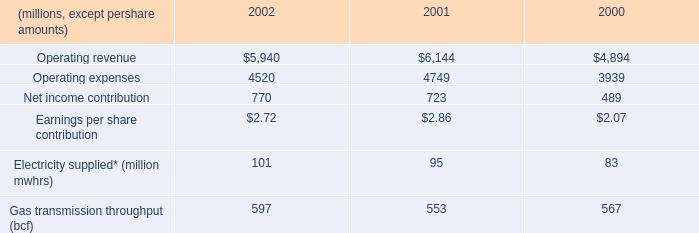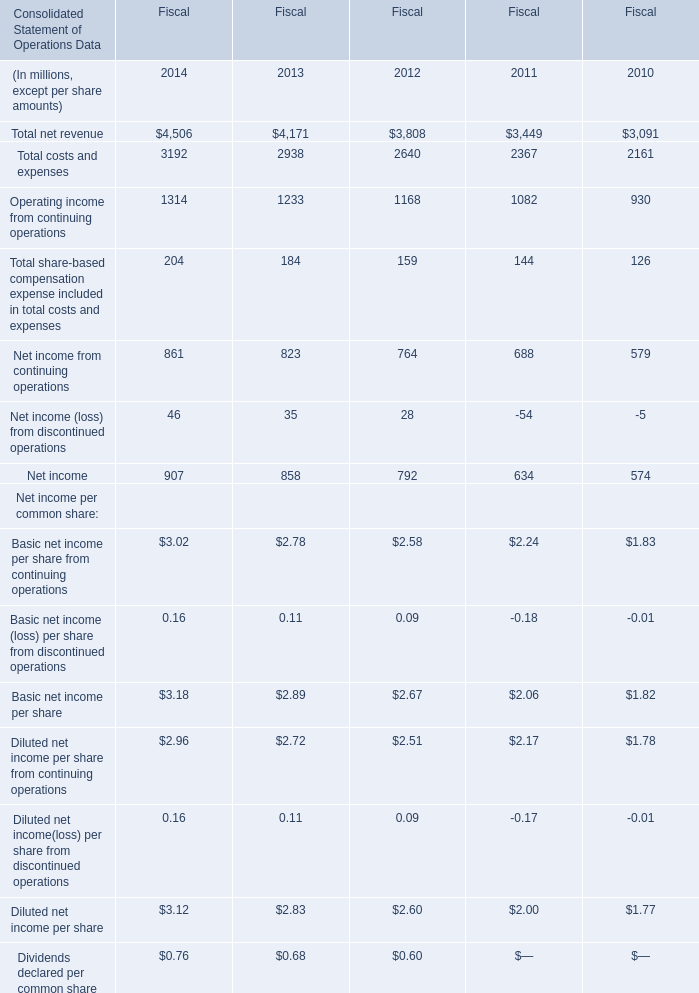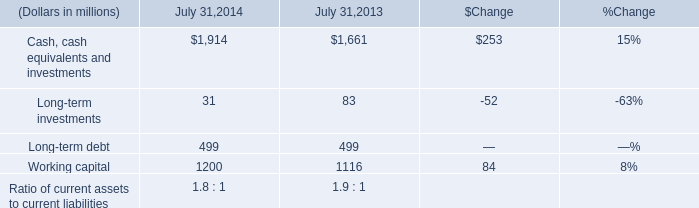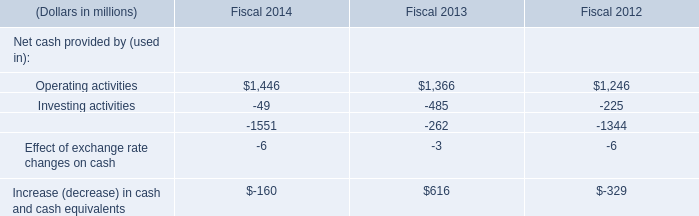What's the increasing rate of Net income in 2014 for Fiscal? 
Computations: ((907 - 858) / 858)
Answer: 0.05711. 